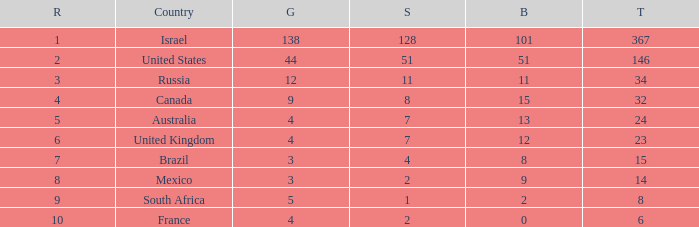What is the gold medal count for the country with a total greater than 32 and more than 128 silvers? None. Would you mind parsing the complete table? {'header': ['R', 'Country', 'G', 'S', 'B', 'T'], 'rows': [['1', 'Israel', '138', '128', '101', '367'], ['2', 'United States', '44', '51', '51', '146'], ['3', 'Russia', '12', '11', '11', '34'], ['4', 'Canada', '9', '8', '15', '32'], ['5', 'Australia', '4', '7', '13', '24'], ['6', 'United Kingdom', '4', '7', '12', '23'], ['7', 'Brazil', '3', '4', '8', '15'], ['8', 'Mexico', '3', '2', '9', '14'], ['9', 'South Africa', '5', '1', '2', '8'], ['10', 'France', '4', '2', '0', '6']]} 